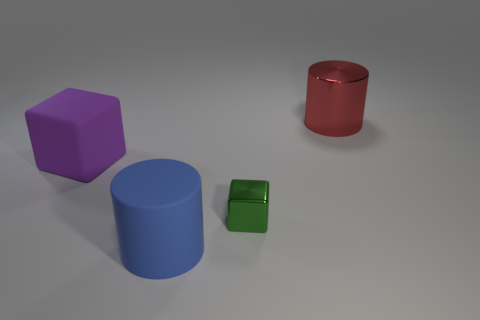Add 2 large green matte spheres. How many objects exist? 6 Add 4 small shiny blocks. How many small shiny blocks are left? 5 Add 2 big red shiny cylinders. How many big red shiny cylinders exist? 3 Subtract 1 purple blocks. How many objects are left? 3 Subtract all large purple matte cubes. Subtract all large blue matte things. How many objects are left? 2 